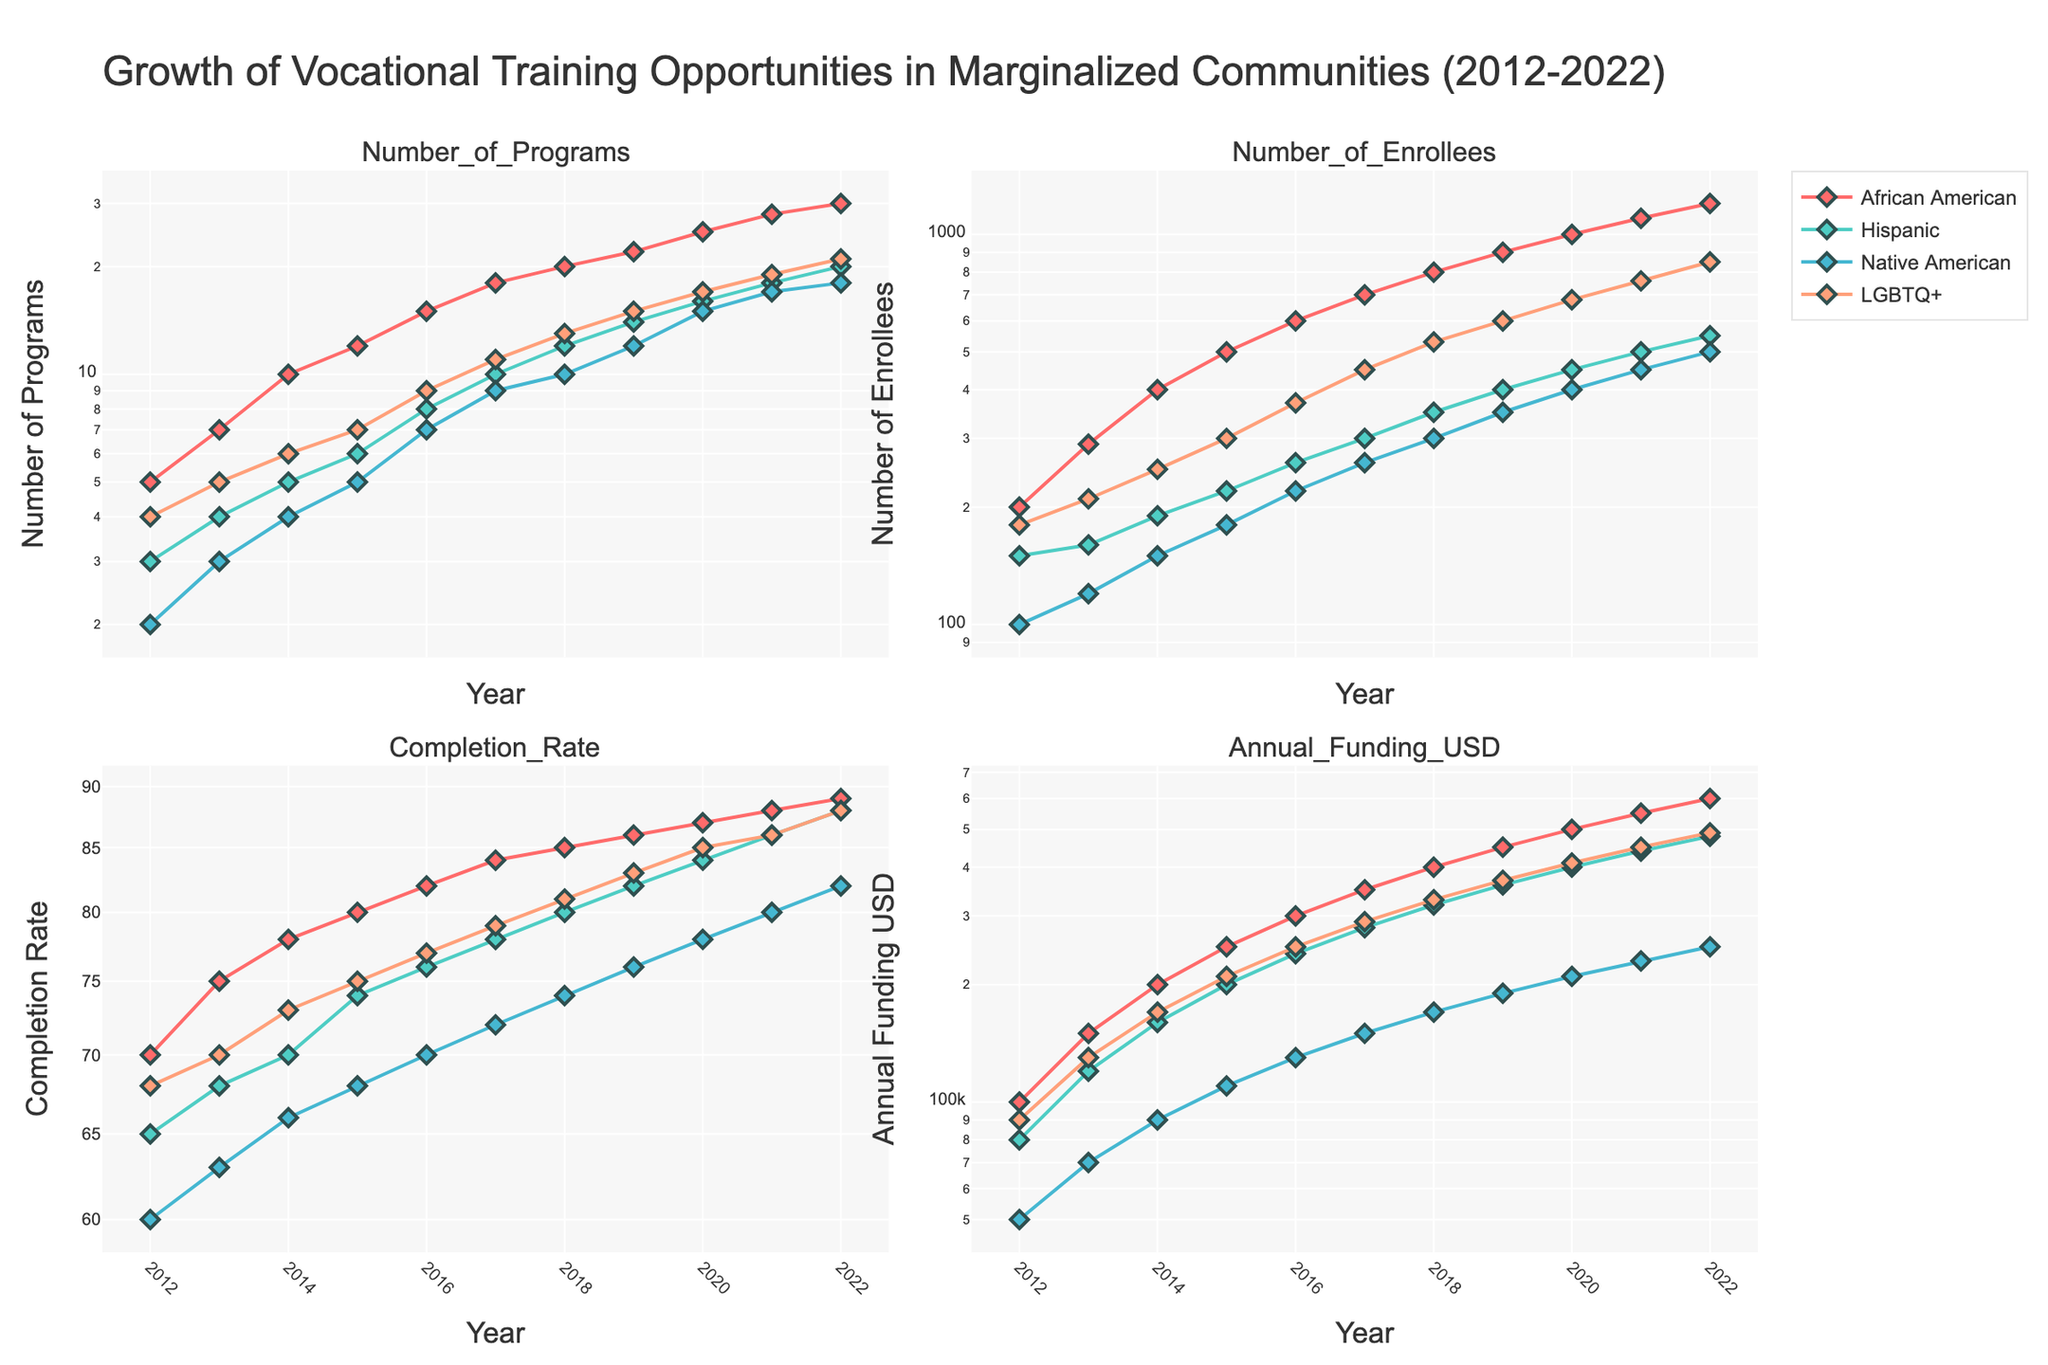What is the title of the figure? The title of the figure is clearly shown at the top. It reads "Growth of Vocational Training Opportunities in Marginalized Communities (2012-2022)".
Answer: Growth of Vocational Training Opportunities in Marginalized Communities (2012-2022) Which community received the highest number of vocational training programs by 2022? By looking at the top-right subplot that shows the 'Number of Programs', we can see that in 2022, the African American community had the highest number of vocational training programs compared to the other groups.
Answer: African American How does the annual funding compare between the African American and Hispanic communities in 2020? By referring to the bottom-right subplot which shows 'Annual Funding USD', we can see that in 2020, the annual funding for the African American community is higher compared to the Hispanic community. The African American community has approximately $500,000, while the Hispanic community has about $400,000 in funding.
Answer: African American > Hispanic Which community showed the fastest growth in the number of enrollees from 2012 to 2022? To determine this, we look at the top-left subplot that displays the 'Number of Enrollees'. Observing the trends, we see that the African American community experienced the highest growth rate, as their number of enrollees increased most steeply over the decade compared to the other communities.
Answer: African American What is the general trend in completion rates among all communities over the past decade? The bottom-left subplot shows 'Completion Rate'. Observing this subplot, it's evident that all communities show an upward trend in completion rates, indicating improvement in the percentage of enrollees completing the programs over time.
Answer: Upward trend Which community had the highest completion rate in 2022, and what was it? Looking at the bottom-left subplot, we see that in 2022, the African American community had the highest completion rate, with a value close to 89%.
Answer: African American, 89% Compare the funding trends between Native American and LGBTQ+ communities from 2012 to 2022. In the bottom-right subplot that shows 'Annual Funding USD', both communities display an upward trend in funding over the decade. However, the LGBTQ+ community's funding increased more steeply and reached approximately $490,000 by 2022, whereas the Native American community's funding increased at a slower rate and reached about $250,000 by 2022.
Answer: LGBTQ+ > Native American Which community had the lowest number of vocational training programs in 2012 and how many were there? The top-right subplot shows the 'Number of Programs' in 2012. The Native American community had the lowest number of programs in that year, with only 2 programs.
Answer: Native American, 2 